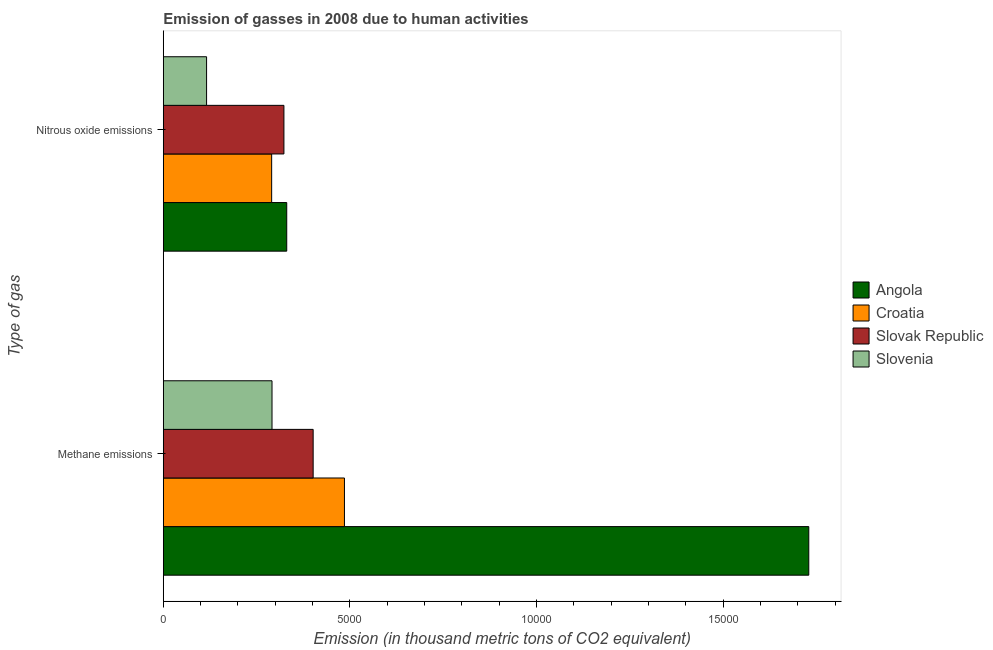How many different coloured bars are there?
Make the answer very short. 4. How many groups of bars are there?
Your answer should be compact. 2. How many bars are there on the 2nd tick from the top?
Provide a short and direct response. 4. What is the label of the 2nd group of bars from the top?
Make the answer very short. Methane emissions. What is the amount of nitrous oxide emissions in Croatia?
Keep it short and to the point. 2902.8. Across all countries, what is the maximum amount of nitrous oxide emissions?
Offer a very short reply. 3307. Across all countries, what is the minimum amount of methane emissions?
Make the answer very short. 2912.5. In which country was the amount of nitrous oxide emissions maximum?
Your answer should be very brief. Angola. In which country was the amount of methane emissions minimum?
Ensure brevity in your answer.  Slovenia. What is the total amount of methane emissions in the graph?
Make the answer very short. 2.91e+04. What is the difference between the amount of methane emissions in Angola and that in Slovak Republic?
Ensure brevity in your answer.  1.33e+04. What is the difference between the amount of methane emissions in Slovenia and the amount of nitrous oxide emissions in Slovak Republic?
Offer a very short reply. -318.9. What is the average amount of methane emissions per country?
Make the answer very short. 7268.3. What is the difference between the amount of nitrous oxide emissions and amount of methane emissions in Croatia?
Offer a terse response. -1950.5. What is the ratio of the amount of methane emissions in Slovenia to that in Croatia?
Your answer should be very brief. 0.6. What does the 3rd bar from the top in Nitrous oxide emissions represents?
Provide a succinct answer. Croatia. What does the 2nd bar from the bottom in Nitrous oxide emissions represents?
Ensure brevity in your answer.  Croatia. Are all the bars in the graph horizontal?
Give a very brief answer. Yes. What is the difference between two consecutive major ticks on the X-axis?
Your answer should be very brief. 5000. Are the values on the major ticks of X-axis written in scientific E-notation?
Provide a short and direct response. No. Does the graph contain any zero values?
Provide a succinct answer. No. Does the graph contain grids?
Offer a terse response. No. How many legend labels are there?
Ensure brevity in your answer.  4. What is the title of the graph?
Provide a succinct answer. Emission of gasses in 2008 due to human activities. What is the label or title of the X-axis?
Offer a terse response. Emission (in thousand metric tons of CO2 equivalent). What is the label or title of the Y-axis?
Ensure brevity in your answer.  Type of gas. What is the Emission (in thousand metric tons of CO2 equivalent) in Angola in Methane emissions?
Make the answer very short. 1.73e+04. What is the Emission (in thousand metric tons of CO2 equivalent) in Croatia in Methane emissions?
Give a very brief answer. 4853.3. What is the Emission (in thousand metric tons of CO2 equivalent) in Slovak Republic in Methane emissions?
Give a very brief answer. 4014.6. What is the Emission (in thousand metric tons of CO2 equivalent) of Slovenia in Methane emissions?
Make the answer very short. 2912.5. What is the Emission (in thousand metric tons of CO2 equivalent) of Angola in Nitrous oxide emissions?
Ensure brevity in your answer.  3307. What is the Emission (in thousand metric tons of CO2 equivalent) in Croatia in Nitrous oxide emissions?
Your response must be concise. 2902.8. What is the Emission (in thousand metric tons of CO2 equivalent) of Slovak Republic in Nitrous oxide emissions?
Your answer should be very brief. 3231.4. What is the Emission (in thousand metric tons of CO2 equivalent) of Slovenia in Nitrous oxide emissions?
Your answer should be very brief. 1159.5. Across all Type of gas, what is the maximum Emission (in thousand metric tons of CO2 equivalent) of Angola?
Provide a short and direct response. 1.73e+04. Across all Type of gas, what is the maximum Emission (in thousand metric tons of CO2 equivalent) in Croatia?
Give a very brief answer. 4853.3. Across all Type of gas, what is the maximum Emission (in thousand metric tons of CO2 equivalent) in Slovak Republic?
Make the answer very short. 4014.6. Across all Type of gas, what is the maximum Emission (in thousand metric tons of CO2 equivalent) of Slovenia?
Give a very brief answer. 2912.5. Across all Type of gas, what is the minimum Emission (in thousand metric tons of CO2 equivalent) in Angola?
Make the answer very short. 3307. Across all Type of gas, what is the minimum Emission (in thousand metric tons of CO2 equivalent) of Croatia?
Provide a succinct answer. 2902.8. Across all Type of gas, what is the minimum Emission (in thousand metric tons of CO2 equivalent) of Slovak Republic?
Your answer should be very brief. 3231.4. Across all Type of gas, what is the minimum Emission (in thousand metric tons of CO2 equivalent) of Slovenia?
Offer a very short reply. 1159.5. What is the total Emission (in thousand metric tons of CO2 equivalent) of Angola in the graph?
Keep it short and to the point. 2.06e+04. What is the total Emission (in thousand metric tons of CO2 equivalent) in Croatia in the graph?
Your response must be concise. 7756.1. What is the total Emission (in thousand metric tons of CO2 equivalent) of Slovak Republic in the graph?
Ensure brevity in your answer.  7246. What is the total Emission (in thousand metric tons of CO2 equivalent) in Slovenia in the graph?
Ensure brevity in your answer.  4072. What is the difference between the Emission (in thousand metric tons of CO2 equivalent) of Angola in Methane emissions and that in Nitrous oxide emissions?
Keep it short and to the point. 1.40e+04. What is the difference between the Emission (in thousand metric tons of CO2 equivalent) in Croatia in Methane emissions and that in Nitrous oxide emissions?
Offer a very short reply. 1950.5. What is the difference between the Emission (in thousand metric tons of CO2 equivalent) of Slovak Republic in Methane emissions and that in Nitrous oxide emissions?
Give a very brief answer. 783.2. What is the difference between the Emission (in thousand metric tons of CO2 equivalent) in Slovenia in Methane emissions and that in Nitrous oxide emissions?
Offer a very short reply. 1753. What is the difference between the Emission (in thousand metric tons of CO2 equivalent) of Angola in Methane emissions and the Emission (in thousand metric tons of CO2 equivalent) of Croatia in Nitrous oxide emissions?
Keep it short and to the point. 1.44e+04. What is the difference between the Emission (in thousand metric tons of CO2 equivalent) of Angola in Methane emissions and the Emission (in thousand metric tons of CO2 equivalent) of Slovak Republic in Nitrous oxide emissions?
Offer a terse response. 1.41e+04. What is the difference between the Emission (in thousand metric tons of CO2 equivalent) of Angola in Methane emissions and the Emission (in thousand metric tons of CO2 equivalent) of Slovenia in Nitrous oxide emissions?
Offer a terse response. 1.61e+04. What is the difference between the Emission (in thousand metric tons of CO2 equivalent) of Croatia in Methane emissions and the Emission (in thousand metric tons of CO2 equivalent) of Slovak Republic in Nitrous oxide emissions?
Give a very brief answer. 1621.9. What is the difference between the Emission (in thousand metric tons of CO2 equivalent) of Croatia in Methane emissions and the Emission (in thousand metric tons of CO2 equivalent) of Slovenia in Nitrous oxide emissions?
Ensure brevity in your answer.  3693.8. What is the difference between the Emission (in thousand metric tons of CO2 equivalent) of Slovak Republic in Methane emissions and the Emission (in thousand metric tons of CO2 equivalent) of Slovenia in Nitrous oxide emissions?
Give a very brief answer. 2855.1. What is the average Emission (in thousand metric tons of CO2 equivalent) in Angola per Type of gas?
Provide a short and direct response. 1.03e+04. What is the average Emission (in thousand metric tons of CO2 equivalent) of Croatia per Type of gas?
Keep it short and to the point. 3878.05. What is the average Emission (in thousand metric tons of CO2 equivalent) in Slovak Republic per Type of gas?
Your response must be concise. 3623. What is the average Emission (in thousand metric tons of CO2 equivalent) of Slovenia per Type of gas?
Make the answer very short. 2036. What is the difference between the Emission (in thousand metric tons of CO2 equivalent) in Angola and Emission (in thousand metric tons of CO2 equivalent) in Croatia in Methane emissions?
Make the answer very short. 1.24e+04. What is the difference between the Emission (in thousand metric tons of CO2 equivalent) of Angola and Emission (in thousand metric tons of CO2 equivalent) of Slovak Republic in Methane emissions?
Provide a short and direct response. 1.33e+04. What is the difference between the Emission (in thousand metric tons of CO2 equivalent) of Angola and Emission (in thousand metric tons of CO2 equivalent) of Slovenia in Methane emissions?
Provide a succinct answer. 1.44e+04. What is the difference between the Emission (in thousand metric tons of CO2 equivalent) in Croatia and Emission (in thousand metric tons of CO2 equivalent) in Slovak Republic in Methane emissions?
Your response must be concise. 838.7. What is the difference between the Emission (in thousand metric tons of CO2 equivalent) in Croatia and Emission (in thousand metric tons of CO2 equivalent) in Slovenia in Methane emissions?
Give a very brief answer. 1940.8. What is the difference between the Emission (in thousand metric tons of CO2 equivalent) of Slovak Republic and Emission (in thousand metric tons of CO2 equivalent) of Slovenia in Methane emissions?
Give a very brief answer. 1102.1. What is the difference between the Emission (in thousand metric tons of CO2 equivalent) in Angola and Emission (in thousand metric tons of CO2 equivalent) in Croatia in Nitrous oxide emissions?
Your answer should be very brief. 404.2. What is the difference between the Emission (in thousand metric tons of CO2 equivalent) of Angola and Emission (in thousand metric tons of CO2 equivalent) of Slovak Republic in Nitrous oxide emissions?
Your response must be concise. 75.6. What is the difference between the Emission (in thousand metric tons of CO2 equivalent) in Angola and Emission (in thousand metric tons of CO2 equivalent) in Slovenia in Nitrous oxide emissions?
Give a very brief answer. 2147.5. What is the difference between the Emission (in thousand metric tons of CO2 equivalent) in Croatia and Emission (in thousand metric tons of CO2 equivalent) in Slovak Republic in Nitrous oxide emissions?
Provide a succinct answer. -328.6. What is the difference between the Emission (in thousand metric tons of CO2 equivalent) in Croatia and Emission (in thousand metric tons of CO2 equivalent) in Slovenia in Nitrous oxide emissions?
Your answer should be very brief. 1743.3. What is the difference between the Emission (in thousand metric tons of CO2 equivalent) of Slovak Republic and Emission (in thousand metric tons of CO2 equivalent) of Slovenia in Nitrous oxide emissions?
Ensure brevity in your answer.  2071.9. What is the ratio of the Emission (in thousand metric tons of CO2 equivalent) of Angola in Methane emissions to that in Nitrous oxide emissions?
Provide a succinct answer. 5.23. What is the ratio of the Emission (in thousand metric tons of CO2 equivalent) of Croatia in Methane emissions to that in Nitrous oxide emissions?
Offer a very short reply. 1.67. What is the ratio of the Emission (in thousand metric tons of CO2 equivalent) of Slovak Republic in Methane emissions to that in Nitrous oxide emissions?
Make the answer very short. 1.24. What is the ratio of the Emission (in thousand metric tons of CO2 equivalent) of Slovenia in Methane emissions to that in Nitrous oxide emissions?
Offer a terse response. 2.51. What is the difference between the highest and the second highest Emission (in thousand metric tons of CO2 equivalent) in Angola?
Offer a very short reply. 1.40e+04. What is the difference between the highest and the second highest Emission (in thousand metric tons of CO2 equivalent) of Croatia?
Make the answer very short. 1950.5. What is the difference between the highest and the second highest Emission (in thousand metric tons of CO2 equivalent) in Slovak Republic?
Ensure brevity in your answer.  783.2. What is the difference between the highest and the second highest Emission (in thousand metric tons of CO2 equivalent) in Slovenia?
Offer a very short reply. 1753. What is the difference between the highest and the lowest Emission (in thousand metric tons of CO2 equivalent) of Angola?
Provide a succinct answer. 1.40e+04. What is the difference between the highest and the lowest Emission (in thousand metric tons of CO2 equivalent) of Croatia?
Give a very brief answer. 1950.5. What is the difference between the highest and the lowest Emission (in thousand metric tons of CO2 equivalent) of Slovak Republic?
Offer a terse response. 783.2. What is the difference between the highest and the lowest Emission (in thousand metric tons of CO2 equivalent) of Slovenia?
Your response must be concise. 1753. 